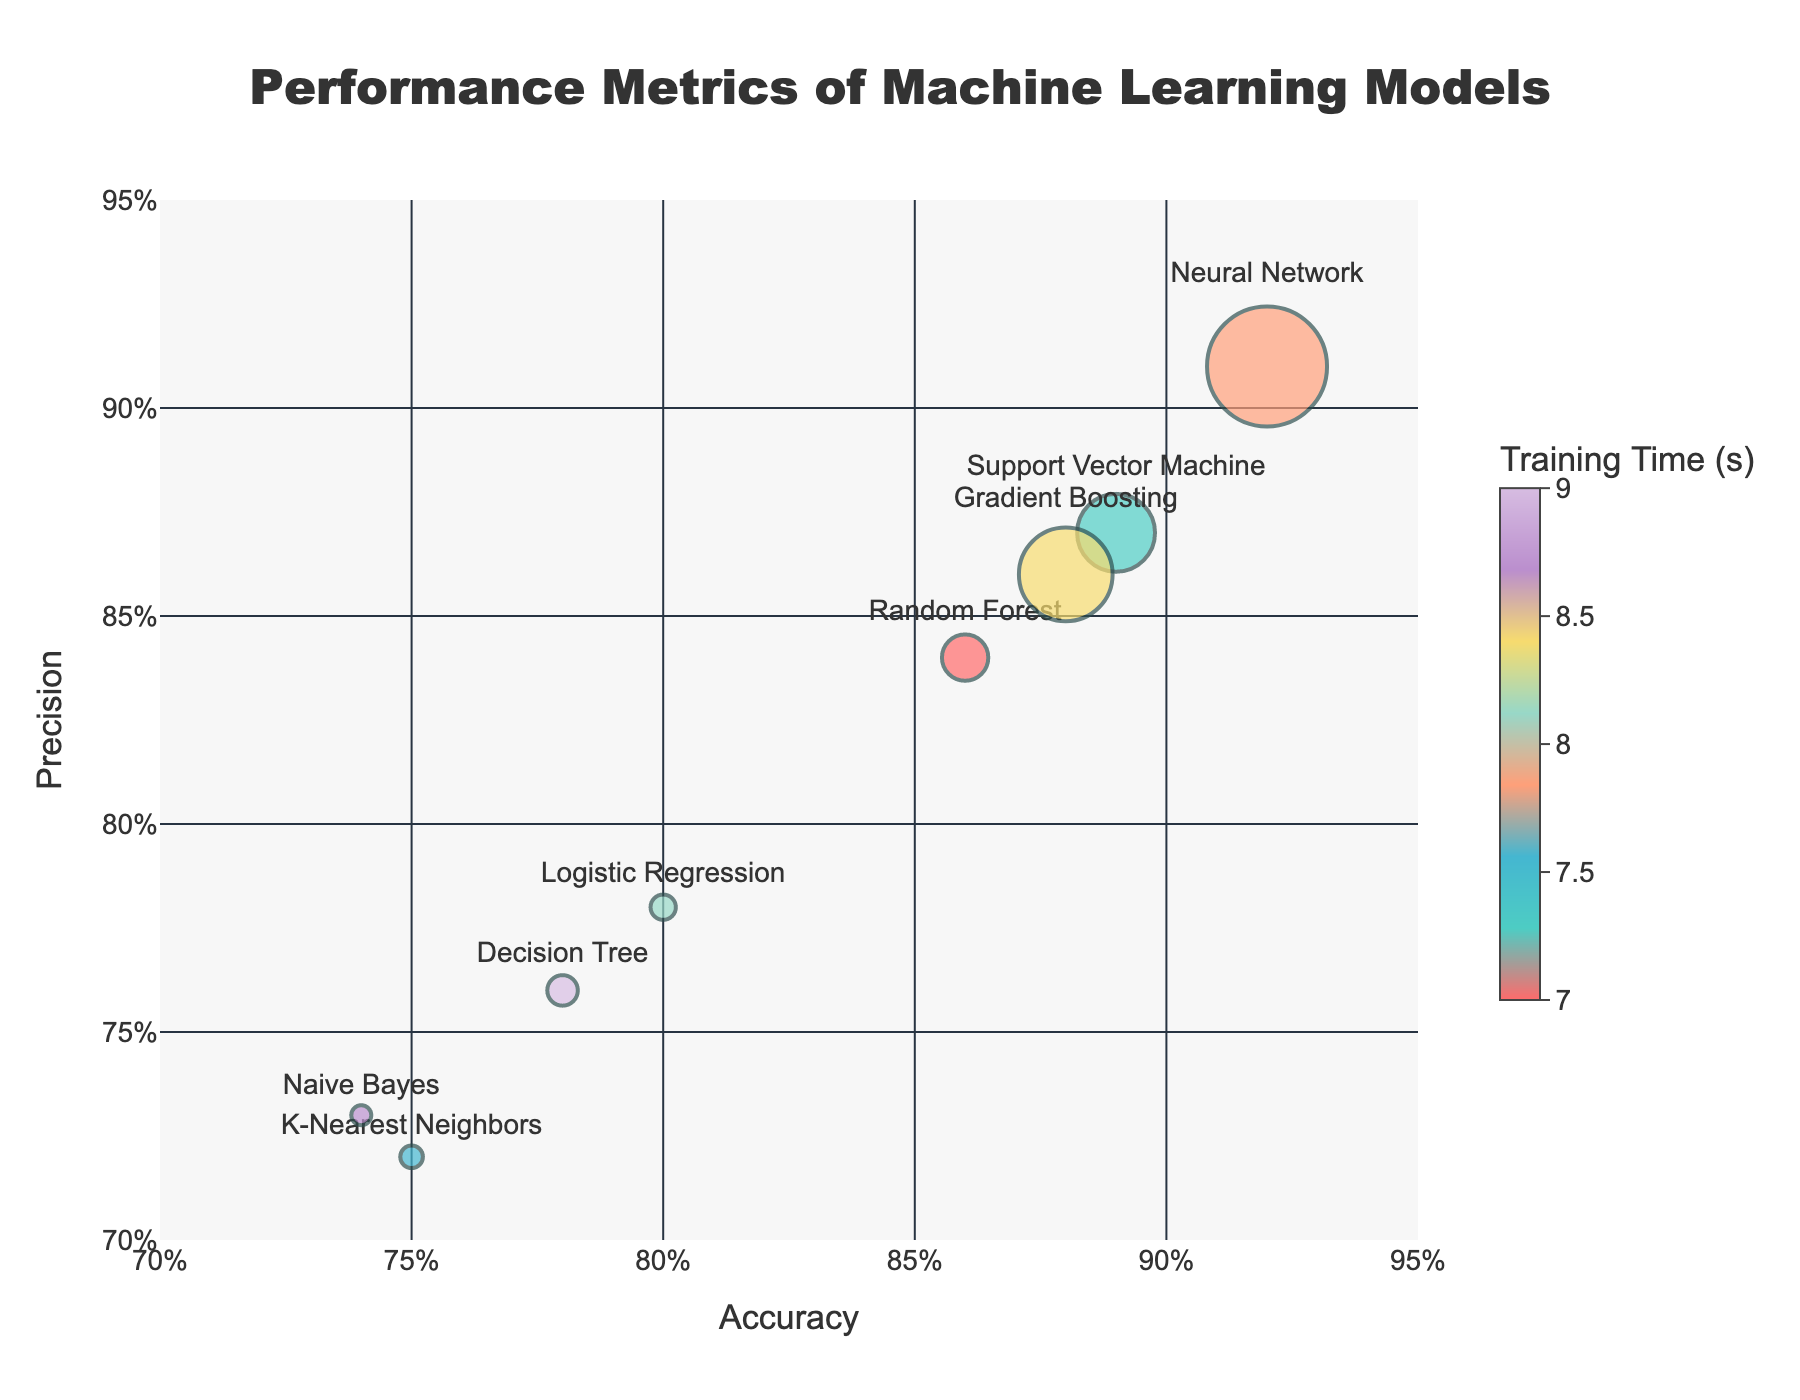What is the title of the chart? The title of the chart is placed at the top center. It provides an overview of what the chart represents. In this case, it reads "Performance Metrics of Machine Learning Models".
Answer: "Performance Metrics of Machine Learning Models" How many machine learning models are plotted in the chart? By counting the number of distinct points (or bubbles) marked on the chart, we can see there are 8 different colors and model names on the chart.
Answer: 8 Which machine learning model has the largest training time? The size of each bubble correlates with the training time. The largest bubble represents the model with the highest training time. In this case, the bubble for the Neural Network model is the largest.
Answer: Neural Network What is the accuracy of the Support Vector Machine model? Hovering over the bubble labeled with "Support Vector Machine" reveals the performance metrics for this model, including accuracy, which is displayed as 0.89.
Answer: 0.89 Which model has both the highest accuracy and highest precision? By examining the positioning of all bubbles on the plot, we find that the Neural Network model is positioned at the top-most right side, indicating it has the highest accuracy and precision.
Answer: Neural Network How does the decision tree model fare in terms of precision and training time compared to logistic regression? The Decision Tree model's bubble sits at (0.78, 0.76) for accuracy and precision, respectively, with a larger bubble compared to Logistic Regression. This indicates that while the Decision Tree may have slightly lower precision, it has a longer training time.
Answer: Decision Tree has slightly lower precision and longer training time than Logistic Regression What is the relationship between training time and bubble size? The pattern illustrated by the bubble sizes on the chart depicts that larger bubbles correspond to longer training times. For example, Neural Network (largest bubble) has the longest training time.
Answer: Larger bubble size indicates longer training time Which model has the lowest precision, and what is that value? By observing the chart or hovering over the bubbles, the model with the lowest precision bubble (Naive Bayes) is evident, and the precision value is shown as 0.73.
Answer: Naive Bayes; 0.73 Between Gradient Boosting and Random Forest, which model has a higher recall? By examining the hover text details or the relative positions on the vertical axis for recall, Gradient Boosting has a recall of 0.87 compared to Random Forest's recall of 0.85.
Answer: Gradient Boosting has a higher recall What is the average accuracy of all the models displayed? Summing the accuracies of all models (0.86 + 0.89 + 0.75 + 0.92 + 0.80 + 0.88 + 0.74 + 0.78 = 6.62) and then dividing by 8 (the number of models) gives 6.62 / 8 = 0.8275.
Answer: 0.8275 